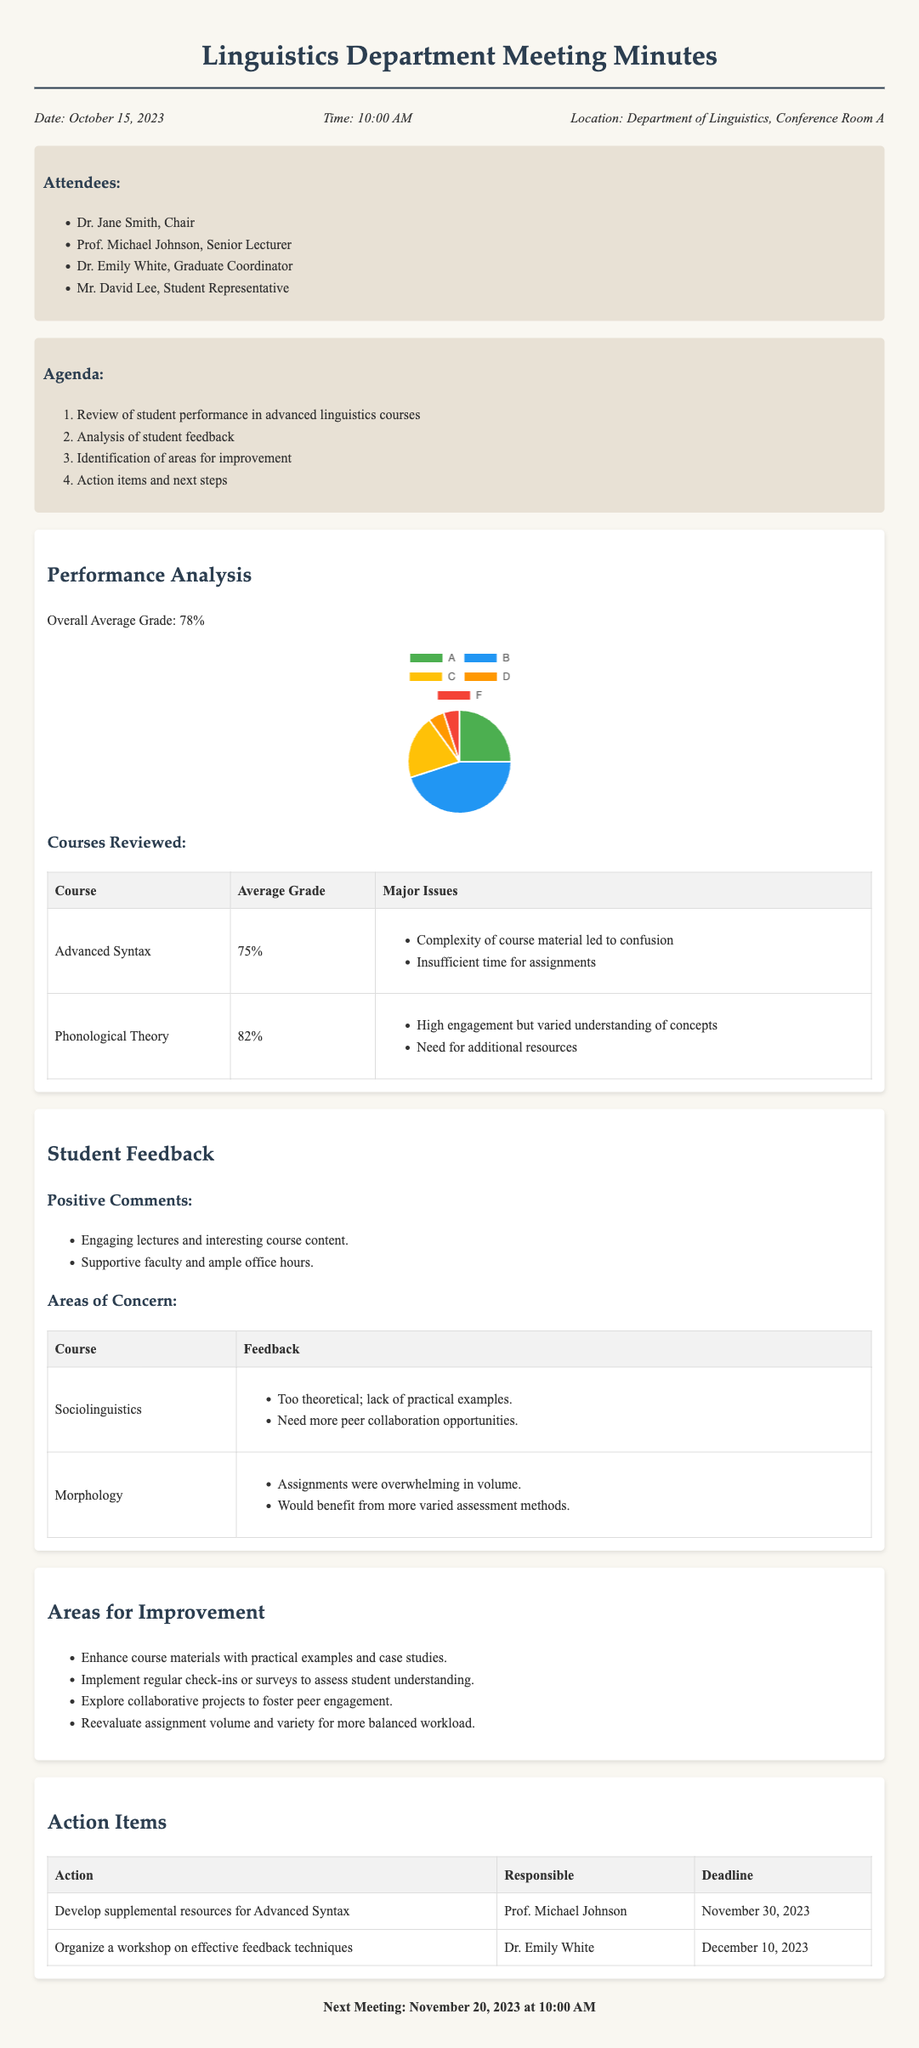What is the date of the meeting? The date of the meeting is explicitly stated in the document's header information.
Answer: October 15, 2023 Who is responsible for developing supplemental resources for Advanced Syntax? The action items section specifies who is assigned each task, including this particular action.
Answer: Prof. Michael Johnson What is the overall average grade reported? The performance analysis section provides the overall average grade of the courses.
Answer: 78% What feedback was provided about the Sociolinguistics course? The student feedback section outlines specific feedback regarding the courses, including Sociolinguistics.
Answer: Too theoretical; lack of practical examples What is one area for improvement mentioned in the document? The areas for improvement section lists suggestions for enhancing the courses.
Answer: Enhance course materials with practical examples and case studies How many attendees were at the meeting? The attendees section lists the names and roles of each participant, allowing for a count.
Answer: 4 What is the deadline for organizing a workshop on effective feedback techniques? The action items table includes deadlines for each task, clearly stating the due date.
Answer: December 10, 2023 What percentage of students received a grade of A? The grade distribution pie chart data indicates specific grade proportions among students.
Answer: 25% 